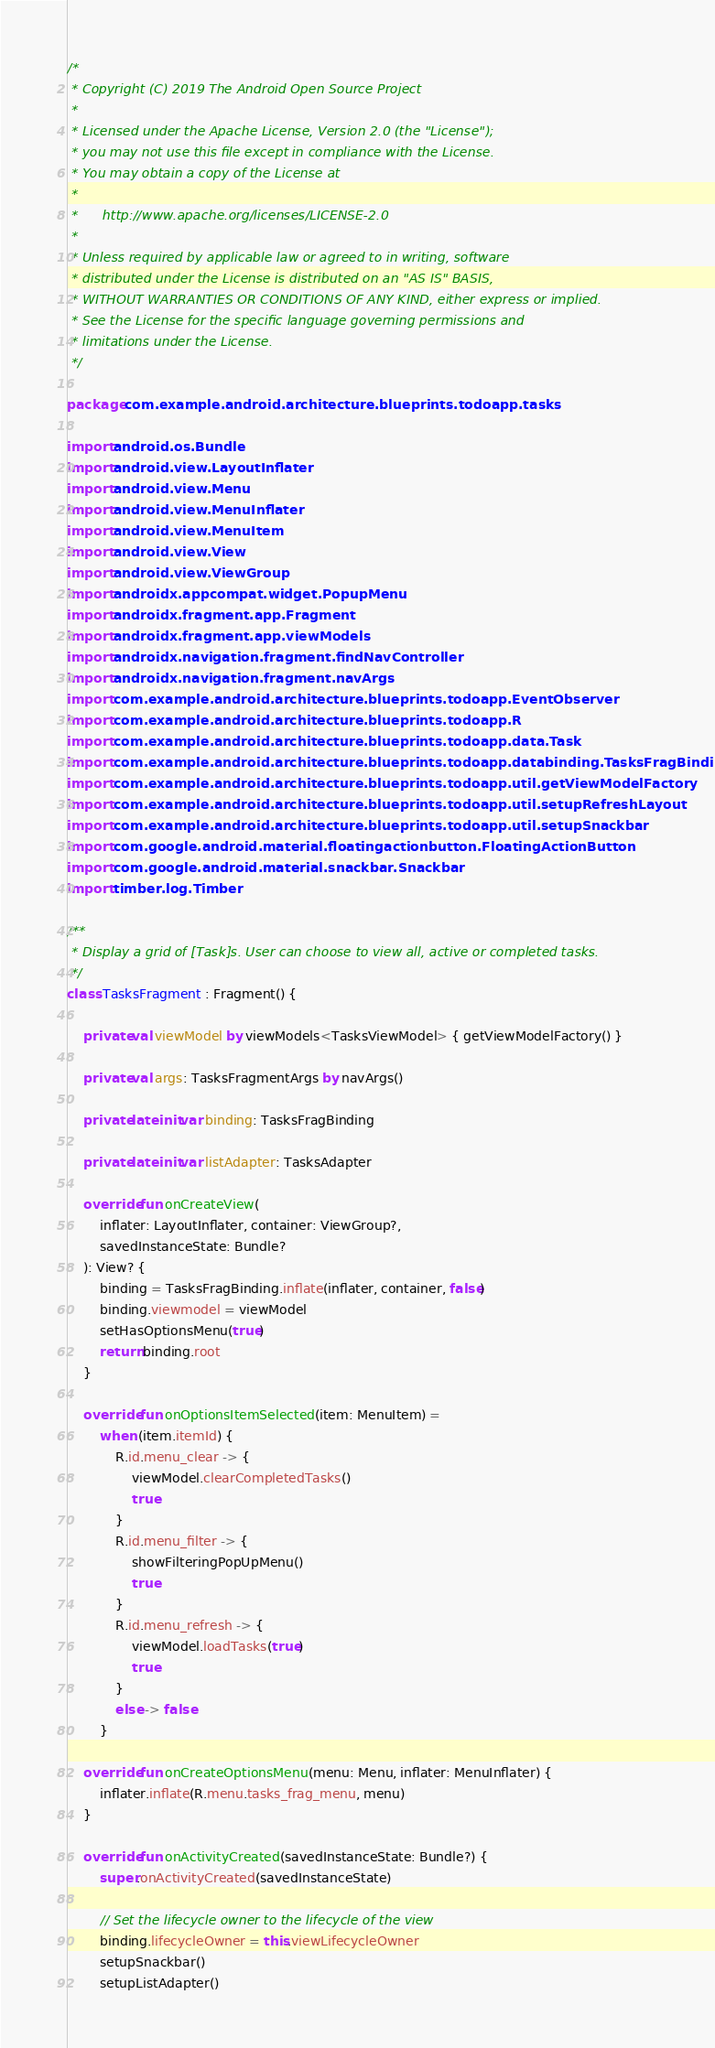<code> <loc_0><loc_0><loc_500><loc_500><_Kotlin_>/*
 * Copyright (C) 2019 The Android Open Source Project
 *
 * Licensed under the Apache License, Version 2.0 (the "License");
 * you may not use this file except in compliance with the License.
 * You may obtain a copy of the License at
 *
 *      http://www.apache.org/licenses/LICENSE-2.0
 *
 * Unless required by applicable law or agreed to in writing, software
 * distributed under the License is distributed on an "AS IS" BASIS,
 * WITHOUT WARRANTIES OR CONDITIONS OF ANY KIND, either express or implied.
 * See the License for the specific language governing permissions and
 * limitations under the License.
 */

package com.example.android.architecture.blueprints.todoapp.tasks

import android.os.Bundle
import android.view.LayoutInflater
import android.view.Menu
import android.view.MenuInflater
import android.view.MenuItem
import android.view.View
import android.view.ViewGroup
import androidx.appcompat.widget.PopupMenu
import androidx.fragment.app.Fragment
import androidx.fragment.app.viewModels
import androidx.navigation.fragment.findNavController
import androidx.navigation.fragment.navArgs
import com.example.android.architecture.blueprints.todoapp.EventObserver
import com.example.android.architecture.blueprints.todoapp.R
import com.example.android.architecture.blueprints.todoapp.data.Task
import com.example.android.architecture.blueprints.todoapp.databinding.TasksFragBinding
import com.example.android.architecture.blueprints.todoapp.util.getViewModelFactory
import com.example.android.architecture.blueprints.todoapp.util.setupRefreshLayout
import com.example.android.architecture.blueprints.todoapp.util.setupSnackbar
import com.google.android.material.floatingactionbutton.FloatingActionButton
import com.google.android.material.snackbar.Snackbar
import timber.log.Timber

/**
 * Display a grid of [Task]s. User can choose to view all, active or completed tasks.
 */
class TasksFragment : Fragment() {

    private val viewModel by viewModels<TasksViewModel> { getViewModelFactory() }

    private val args: TasksFragmentArgs by navArgs()

    private lateinit var binding: TasksFragBinding

    private lateinit var listAdapter: TasksAdapter

    override fun onCreateView(
        inflater: LayoutInflater, container: ViewGroup?,
        savedInstanceState: Bundle?
    ): View? {
        binding = TasksFragBinding.inflate(inflater, container, false)
        binding.viewmodel = viewModel
        setHasOptionsMenu(true)
        return binding.root
    }

    override fun onOptionsItemSelected(item: MenuItem) =
        when (item.itemId) {
            R.id.menu_clear -> {
                viewModel.clearCompletedTasks()
                true
            }
            R.id.menu_filter -> {
                showFilteringPopUpMenu()
                true
            }
            R.id.menu_refresh -> {
                viewModel.loadTasks(true)
                true
            }
            else -> false
        }

    override fun onCreateOptionsMenu(menu: Menu, inflater: MenuInflater) {
        inflater.inflate(R.menu.tasks_frag_menu, menu)
    }

    override fun onActivityCreated(savedInstanceState: Bundle?) {
        super.onActivityCreated(savedInstanceState)

        // Set the lifecycle owner to the lifecycle of the view
        binding.lifecycleOwner = this.viewLifecycleOwner
        setupSnackbar()
        setupListAdapter()</code> 